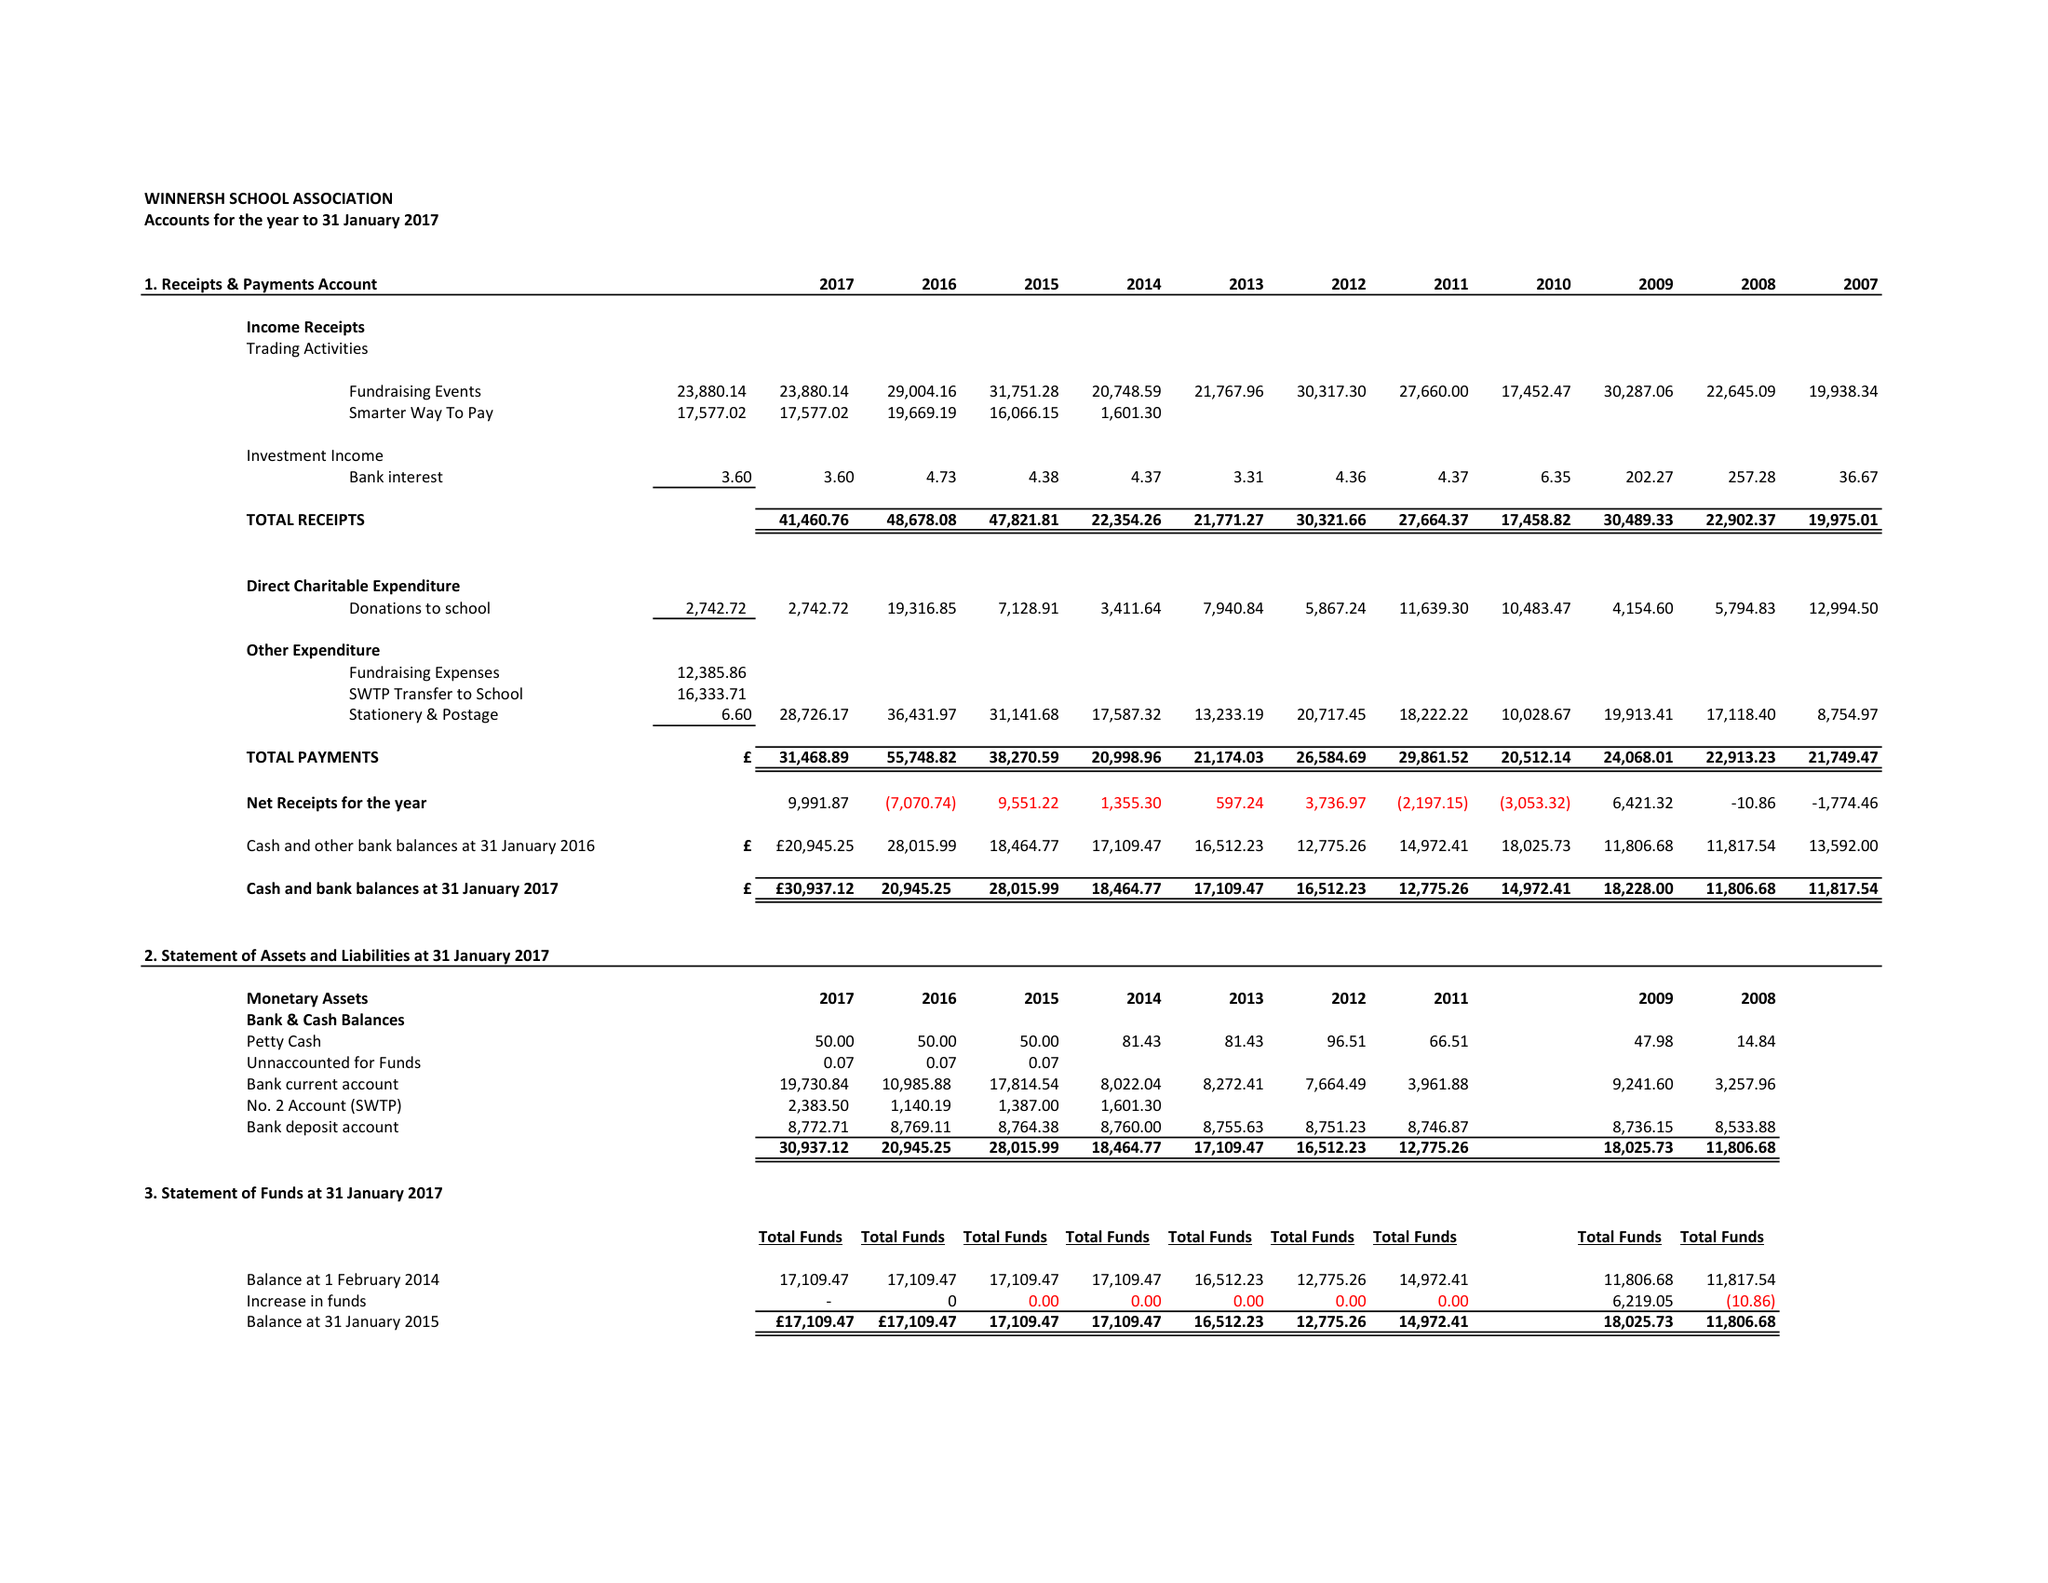What is the value for the address__post_town?
Answer the question using a single word or phrase. WOKINGHAM 